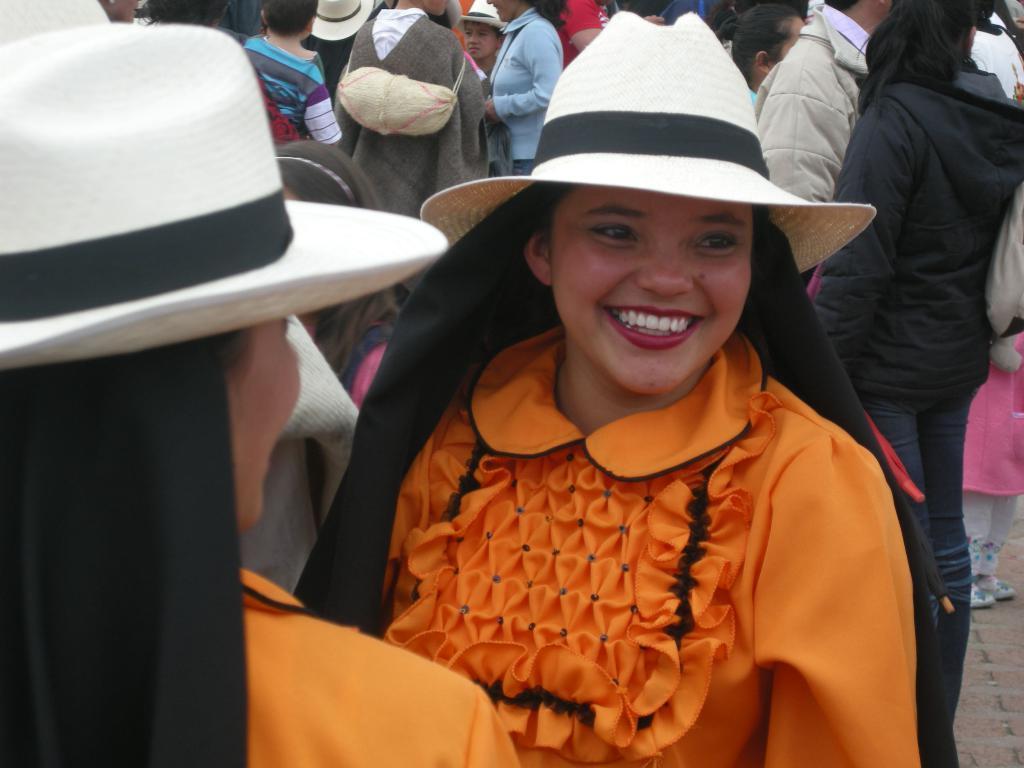Describe this image in one or two sentences. In this picture we can see some people are standing, a woman in the front is smiling, these two persons wore caps. 